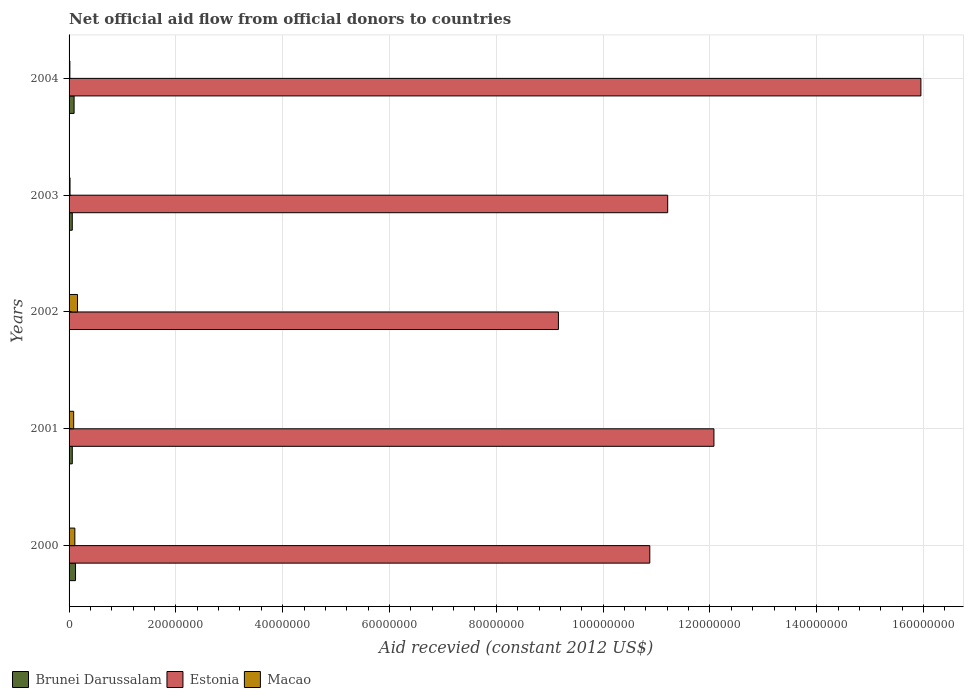Are the number of bars per tick equal to the number of legend labels?
Your answer should be compact. No. How many bars are there on the 1st tick from the top?
Provide a short and direct response. 3. What is the label of the 5th group of bars from the top?
Your answer should be very brief. 2000. In how many cases, is the number of bars for a given year not equal to the number of legend labels?
Provide a short and direct response. 1. What is the total aid received in Estonia in 2004?
Keep it short and to the point. 1.59e+08. Across all years, what is the maximum total aid received in Macao?
Make the answer very short. 1.58e+06. What is the total total aid received in Estonia in the graph?
Keep it short and to the point. 5.93e+08. What is the difference between the total aid received in Brunei Darussalam in 2001 and that in 2003?
Offer a very short reply. 0. What is the difference between the total aid received in Brunei Darussalam in 2004 and the total aid received in Estonia in 2000?
Offer a terse response. -1.08e+08. What is the average total aid received in Macao per year?
Give a very brief answer. 7.70e+05. In the year 2003, what is the difference between the total aid received in Macao and total aid received in Estonia?
Keep it short and to the point. -1.12e+08. In how many years, is the total aid received in Estonia greater than 104000000 US$?
Offer a very short reply. 4. What is the ratio of the total aid received in Brunei Darussalam in 2003 to that in 2004?
Provide a short and direct response. 0.64. What is the difference between the highest and the second highest total aid received in Brunei Darussalam?
Give a very brief answer. 2.70e+05. What is the difference between the highest and the lowest total aid received in Macao?
Keep it short and to the point. 1.43e+06. In how many years, is the total aid received in Brunei Darussalam greater than the average total aid received in Brunei Darussalam taken over all years?
Give a very brief answer. 2. Is it the case that in every year, the sum of the total aid received in Brunei Darussalam and total aid received in Macao is greater than the total aid received in Estonia?
Your answer should be compact. No. Where does the legend appear in the graph?
Ensure brevity in your answer.  Bottom left. How are the legend labels stacked?
Provide a short and direct response. Horizontal. What is the title of the graph?
Provide a succinct answer. Net official aid flow from official donors to countries. Does "Oman" appear as one of the legend labels in the graph?
Make the answer very short. No. What is the label or title of the X-axis?
Your answer should be compact. Aid recevied (constant 2012 US$). What is the label or title of the Y-axis?
Ensure brevity in your answer.  Years. What is the Aid recevied (constant 2012 US$) of Brunei Darussalam in 2000?
Provide a succinct answer. 1.21e+06. What is the Aid recevied (constant 2012 US$) in Estonia in 2000?
Make the answer very short. 1.09e+08. What is the Aid recevied (constant 2012 US$) in Macao in 2000?
Provide a succinct answer. 1.08e+06. What is the Aid recevied (constant 2012 US$) in Estonia in 2001?
Your answer should be compact. 1.21e+08. What is the Aid recevied (constant 2012 US$) in Macao in 2001?
Ensure brevity in your answer.  8.60e+05. What is the Aid recevied (constant 2012 US$) of Estonia in 2002?
Your response must be concise. 9.16e+07. What is the Aid recevied (constant 2012 US$) of Macao in 2002?
Give a very brief answer. 1.58e+06. What is the Aid recevied (constant 2012 US$) in Estonia in 2003?
Keep it short and to the point. 1.12e+08. What is the Aid recevied (constant 2012 US$) in Macao in 2003?
Your answer should be very brief. 1.80e+05. What is the Aid recevied (constant 2012 US$) of Brunei Darussalam in 2004?
Provide a short and direct response. 9.40e+05. What is the Aid recevied (constant 2012 US$) of Estonia in 2004?
Give a very brief answer. 1.59e+08. What is the Aid recevied (constant 2012 US$) in Macao in 2004?
Keep it short and to the point. 1.50e+05. Across all years, what is the maximum Aid recevied (constant 2012 US$) in Brunei Darussalam?
Your answer should be compact. 1.21e+06. Across all years, what is the maximum Aid recevied (constant 2012 US$) of Estonia?
Make the answer very short. 1.59e+08. Across all years, what is the maximum Aid recevied (constant 2012 US$) of Macao?
Your response must be concise. 1.58e+06. Across all years, what is the minimum Aid recevied (constant 2012 US$) of Estonia?
Your answer should be compact. 9.16e+07. What is the total Aid recevied (constant 2012 US$) in Brunei Darussalam in the graph?
Your response must be concise. 3.35e+06. What is the total Aid recevied (constant 2012 US$) in Estonia in the graph?
Offer a very short reply. 5.93e+08. What is the total Aid recevied (constant 2012 US$) of Macao in the graph?
Offer a terse response. 3.85e+06. What is the difference between the Aid recevied (constant 2012 US$) of Estonia in 2000 and that in 2001?
Offer a very short reply. -1.20e+07. What is the difference between the Aid recevied (constant 2012 US$) in Macao in 2000 and that in 2001?
Provide a short and direct response. 2.20e+05. What is the difference between the Aid recevied (constant 2012 US$) of Estonia in 2000 and that in 2002?
Your answer should be compact. 1.71e+07. What is the difference between the Aid recevied (constant 2012 US$) in Macao in 2000 and that in 2002?
Keep it short and to the point. -5.00e+05. What is the difference between the Aid recevied (constant 2012 US$) of Brunei Darussalam in 2000 and that in 2003?
Ensure brevity in your answer.  6.10e+05. What is the difference between the Aid recevied (constant 2012 US$) in Estonia in 2000 and that in 2003?
Give a very brief answer. -3.35e+06. What is the difference between the Aid recevied (constant 2012 US$) in Brunei Darussalam in 2000 and that in 2004?
Offer a very short reply. 2.70e+05. What is the difference between the Aid recevied (constant 2012 US$) of Estonia in 2000 and that in 2004?
Give a very brief answer. -5.08e+07. What is the difference between the Aid recevied (constant 2012 US$) in Macao in 2000 and that in 2004?
Your answer should be very brief. 9.30e+05. What is the difference between the Aid recevied (constant 2012 US$) in Estonia in 2001 and that in 2002?
Provide a short and direct response. 2.91e+07. What is the difference between the Aid recevied (constant 2012 US$) of Macao in 2001 and that in 2002?
Provide a short and direct response. -7.20e+05. What is the difference between the Aid recevied (constant 2012 US$) of Brunei Darussalam in 2001 and that in 2003?
Your answer should be very brief. 0. What is the difference between the Aid recevied (constant 2012 US$) of Estonia in 2001 and that in 2003?
Offer a terse response. 8.66e+06. What is the difference between the Aid recevied (constant 2012 US$) in Macao in 2001 and that in 2003?
Ensure brevity in your answer.  6.80e+05. What is the difference between the Aid recevied (constant 2012 US$) in Brunei Darussalam in 2001 and that in 2004?
Your answer should be very brief. -3.40e+05. What is the difference between the Aid recevied (constant 2012 US$) of Estonia in 2001 and that in 2004?
Provide a short and direct response. -3.88e+07. What is the difference between the Aid recevied (constant 2012 US$) of Macao in 2001 and that in 2004?
Give a very brief answer. 7.10e+05. What is the difference between the Aid recevied (constant 2012 US$) of Estonia in 2002 and that in 2003?
Ensure brevity in your answer.  -2.05e+07. What is the difference between the Aid recevied (constant 2012 US$) in Macao in 2002 and that in 2003?
Your response must be concise. 1.40e+06. What is the difference between the Aid recevied (constant 2012 US$) of Estonia in 2002 and that in 2004?
Make the answer very short. -6.79e+07. What is the difference between the Aid recevied (constant 2012 US$) of Macao in 2002 and that in 2004?
Make the answer very short. 1.43e+06. What is the difference between the Aid recevied (constant 2012 US$) in Brunei Darussalam in 2003 and that in 2004?
Provide a short and direct response. -3.40e+05. What is the difference between the Aid recevied (constant 2012 US$) in Estonia in 2003 and that in 2004?
Provide a short and direct response. -4.74e+07. What is the difference between the Aid recevied (constant 2012 US$) in Macao in 2003 and that in 2004?
Your answer should be compact. 3.00e+04. What is the difference between the Aid recevied (constant 2012 US$) of Brunei Darussalam in 2000 and the Aid recevied (constant 2012 US$) of Estonia in 2001?
Provide a succinct answer. -1.20e+08. What is the difference between the Aid recevied (constant 2012 US$) in Brunei Darussalam in 2000 and the Aid recevied (constant 2012 US$) in Macao in 2001?
Provide a succinct answer. 3.50e+05. What is the difference between the Aid recevied (constant 2012 US$) of Estonia in 2000 and the Aid recevied (constant 2012 US$) of Macao in 2001?
Your answer should be very brief. 1.08e+08. What is the difference between the Aid recevied (constant 2012 US$) in Brunei Darussalam in 2000 and the Aid recevied (constant 2012 US$) in Estonia in 2002?
Offer a very short reply. -9.04e+07. What is the difference between the Aid recevied (constant 2012 US$) in Brunei Darussalam in 2000 and the Aid recevied (constant 2012 US$) in Macao in 2002?
Provide a short and direct response. -3.70e+05. What is the difference between the Aid recevied (constant 2012 US$) in Estonia in 2000 and the Aid recevied (constant 2012 US$) in Macao in 2002?
Make the answer very short. 1.07e+08. What is the difference between the Aid recevied (constant 2012 US$) in Brunei Darussalam in 2000 and the Aid recevied (constant 2012 US$) in Estonia in 2003?
Ensure brevity in your answer.  -1.11e+08. What is the difference between the Aid recevied (constant 2012 US$) of Brunei Darussalam in 2000 and the Aid recevied (constant 2012 US$) of Macao in 2003?
Provide a short and direct response. 1.03e+06. What is the difference between the Aid recevied (constant 2012 US$) in Estonia in 2000 and the Aid recevied (constant 2012 US$) in Macao in 2003?
Your answer should be very brief. 1.09e+08. What is the difference between the Aid recevied (constant 2012 US$) of Brunei Darussalam in 2000 and the Aid recevied (constant 2012 US$) of Estonia in 2004?
Your answer should be compact. -1.58e+08. What is the difference between the Aid recevied (constant 2012 US$) of Brunei Darussalam in 2000 and the Aid recevied (constant 2012 US$) of Macao in 2004?
Your answer should be compact. 1.06e+06. What is the difference between the Aid recevied (constant 2012 US$) in Estonia in 2000 and the Aid recevied (constant 2012 US$) in Macao in 2004?
Offer a very short reply. 1.09e+08. What is the difference between the Aid recevied (constant 2012 US$) of Brunei Darussalam in 2001 and the Aid recevied (constant 2012 US$) of Estonia in 2002?
Offer a very short reply. -9.10e+07. What is the difference between the Aid recevied (constant 2012 US$) in Brunei Darussalam in 2001 and the Aid recevied (constant 2012 US$) in Macao in 2002?
Give a very brief answer. -9.80e+05. What is the difference between the Aid recevied (constant 2012 US$) in Estonia in 2001 and the Aid recevied (constant 2012 US$) in Macao in 2002?
Offer a terse response. 1.19e+08. What is the difference between the Aid recevied (constant 2012 US$) in Brunei Darussalam in 2001 and the Aid recevied (constant 2012 US$) in Estonia in 2003?
Provide a succinct answer. -1.11e+08. What is the difference between the Aid recevied (constant 2012 US$) in Estonia in 2001 and the Aid recevied (constant 2012 US$) in Macao in 2003?
Your response must be concise. 1.21e+08. What is the difference between the Aid recevied (constant 2012 US$) in Brunei Darussalam in 2001 and the Aid recevied (constant 2012 US$) in Estonia in 2004?
Provide a short and direct response. -1.59e+08. What is the difference between the Aid recevied (constant 2012 US$) in Brunei Darussalam in 2001 and the Aid recevied (constant 2012 US$) in Macao in 2004?
Offer a terse response. 4.50e+05. What is the difference between the Aid recevied (constant 2012 US$) in Estonia in 2001 and the Aid recevied (constant 2012 US$) in Macao in 2004?
Offer a very short reply. 1.21e+08. What is the difference between the Aid recevied (constant 2012 US$) of Estonia in 2002 and the Aid recevied (constant 2012 US$) of Macao in 2003?
Offer a very short reply. 9.14e+07. What is the difference between the Aid recevied (constant 2012 US$) of Estonia in 2002 and the Aid recevied (constant 2012 US$) of Macao in 2004?
Ensure brevity in your answer.  9.15e+07. What is the difference between the Aid recevied (constant 2012 US$) in Brunei Darussalam in 2003 and the Aid recevied (constant 2012 US$) in Estonia in 2004?
Your response must be concise. -1.59e+08. What is the difference between the Aid recevied (constant 2012 US$) in Estonia in 2003 and the Aid recevied (constant 2012 US$) in Macao in 2004?
Provide a succinct answer. 1.12e+08. What is the average Aid recevied (constant 2012 US$) in Brunei Darussalam per year?
Your answer should be compact. 6.70e+05. What is the average Aid recevied (constant 2012 US$) of Estonia per year?
Offer a very short reply. 1.19e+08. What is the average Aid recevied (constant 2012 US$) of Macao per year?
Offer a terse response. 7.70e+05. In the year 2000, what is the difference between the Aid recevied (constant 2012 US$) of Brunei Darussalam and Aid recevied (constant 2012 US$) of Estonia?
Your response must be concise. -1.08e+08. In the year 2000, what is the difference between the Aid recevied (constant 2012 US$) in Brunei Darussalam and Aid recevied (constant 2012 US$) in Macao?
Offer a very short reply. 1.30e+05. In the year 2000, what is the difference between the Aid recevied (constant 2012 US$) of Estonia and Aid recevied (constant 2012 US$) of Macao?
Ensure brevity in your answer.  1.08e+08. In the year 2001, what is the difference between the Aid recevied (constant 2012 US$) of Brunei Darussalam and Aid recevied (constant 2012 US$) of Estonia?
Provide a short and direct response. -1.20e+08. In the year 2001, what is the difference between the Aid recevied (constant 2012 US$) of Brunei Darussalam and Aid recevied (constant 2012 US$) of Macao?
Offer a very short reply. -2.60e+05. In the year 2001, what is the difference between the Aid recevied (constant 2012 US$) in Estonia and Aid recevied (constant 2012 US$) in Macao?
Provide a succinct answer. 1.20e+08. In the year 2002, what is the difference between the Aid recevied (constant 2012 US$) of Estonia and Aid recevied (constant 2012 US$) of Macao?
Ensure brevity in your answer.  9.00e+07. In the year 2003, what is the difference between the Aid recevied (constant 2012 US$) in Brunei Darussalam and Aid recevied (constant 2012 US$) in Estonia?
Ensure brevity in your answer.  -1.11e+08. In the year 2003, what is the difference between the Aid recevied (constant 2012 US$) of Brunei Darussalam and Aid recevied (constant 2012 US$) of Macao?
Make the answer very short. 4.20e+05. In the year 2003, what is the difference between the Aid recevied (constant 2012 US$) of Estonia and Aid recevied (constant 2012 US$) of Macao?
Your answer should be compact. 1.12e+08. In the year 2004, what is the difference between the Aid recevied (constant 2012 US$) in Brunei Darussalam and Aid recevied (constant 2012 US$) in Estonia?
Provide a succinct answer. -1.59e+08. In the year 2004, what is the difference between the Aid recevied (constant 2012 US$) of Brunei Darussalam and Aid recevied (constant 2012 US$) of Macao?
Provide a short and direct response. 7.90e+05. In the year 2004, what is the difference between the Aid recevied (constant 2012 US$) of Estonia and Aid recevied (constant 2012 US$) of Macao?
Offer a terse response. 1.59e+08. What is the ratio of the Aid recevied (constant 2012 US$) of Brunei Darussalam in 2000 to that in 2001?
Provide a succinct answer. 2.02. What is the ratio of the Aid recevied (constant 2012 US$) in Estonia in 2000 to that in 2001?
Ensure brevity in your answer.  0.9. What is the ratio of the Aid recevied (constant 2012 US$) of Macao in 2000 to that in 2001?
Your answer should be very brief. 1.26. What is the ratio of the Aid recevied (constant 2012 US$) in Estonia in 2000 to that in 2002?
Your answer should be compact. 1.19. What is the ratio of the Aid recevied (constant 2012 US$) in Macao in 2000 to that in 2002?
Offer a terse response. 0.68. What is the ratio of the Aid recevied (constant 2012 US$) in Brunei Darussalam in 2000 to that in 2003?
Keep it short and to the point. 2.02. What is the ratio of the Aid recevied (constant 2012 US$) of Estonia in 2000 to that in 2003?
Make the answer very short. 0.97. What is the ratio of the Aid recevied (constant 2012 US$) in Brunei Darussalam in 2000 to that in 2004?
Make the answer very short. 1.29. What is the ratio of the Aid recevied (constant 2012 US$) of Estonia in 2000 to that in 2004?
Provide a short and direct response. 0.68. What is the ratio of the Aid recevied (constant 2012 US$) of Estonia in 2001 to that in 2002?
Provide a short and direct response. 1.32. What is the ratio of the Aid recevied (constant 2012 US$) in Macao in 2001 to that in 2002?
Give a very brief answer. 0.54. What is the ratio of the Aid recevied (constant 2012 US$) of Estonia in 2001 to that in 2003?
Give a very brief answer. 1.08. What is the ratio of the Aid recevied (constant 2012 US$) of Macao in 2001 to that in 2003?
Ensure brevity in your answer.  4.78. What is the ratio of the Aid recevied (constant 2012 US$) of Brunei Darussalam in 2001 to that in 2004?
Provide a succinct answer. 0.64. What is the ratio of the Aid recevied (constant 2012 US$) of Estonia in 2001 to that in 2004?
Your answer should be compact. 0.76. What is the ratio of the Aid recevied (constant 2012 US$) of Macao in 2001 to that in 2004?
Your answer should be very brief. 5.73. What is the ratio of the Aid recevied (constant 2012 US$) of Estonia in 2002 to that in 2003?
Offer a very short reply. 0.82. What is the ratio of the Aid recevied (constant 2012 US$) in Macao in 2002 to that in 2003?
Provide a short and direct response. 8.78. What is the ratio of the Aid recevied (constant 2012 US$) of Estonia in 2002 to that in 2004?
Your response must be concise. 0.57. What is the ratio of the Aid recevied (constant 2012 US$) of Macao in 2002 to that in 2004?
Offer a terse response. 10.53. What is the ratio of the Aid recevied (constant 2012 US$) of Brunei Darussalam in 2003 to that in 2004?
Offer a very short reply. 0.64. What is the ratio of the Aid recevied (constant 2012 US$) of Estonia in 2003 to that in 2004?
Offer a very short reply. 0.7. What is the difference between the highest and the second highest Aid recevied (constant 2012 US$) in Brunei Darussalam?
Give a very brief answer. 2.70e+05. What is the difference between the highest and the second highest Aid recevied (constant 2012 US$) in Estonia?
Ensure brevity in your answer.  3.88e+07. What is the difference between the highest and the second highest Aid recevied (constant 2012 US$) of Macao?
Your response must be concise. 5.00e+05. What is the difference between the highest and the lowest Aid recevied (constant 2012 US$) in Brunei Darussalam?
Your answer should be very brief. 1.21e+06. What is the difference between the highest and the lowest Aid recevied (constant 2012 US$) of Estonia?
Make the answer very short. 6.79e+07. What is the difference between the highest and the lowest Aid recevied (constant 2012 US$) in Macao?
Provide a succinct answer. 1.43e+06. 